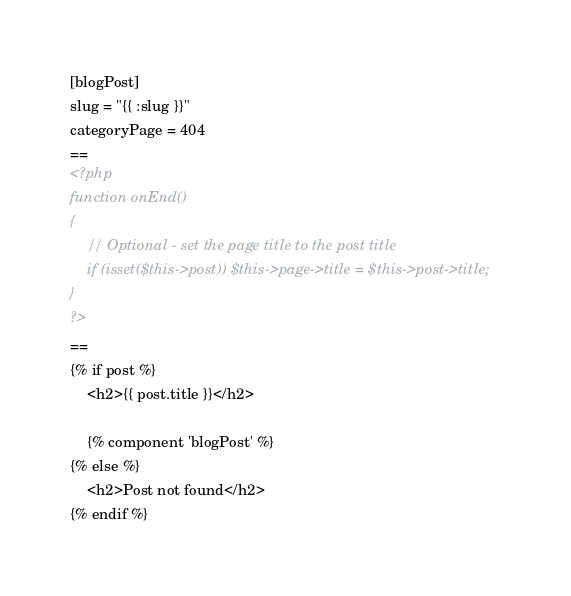<code> <loc_0><loc_0><loc_500><loc_500><_HTML_>
[blogPost]
slug = "{{ :slug }}"
categoryPage = 404
==
<?php
function onEnd()
{
    // Optional - set the page title to the post title
    if (isset($this->post)) $this->page->title = $this->post->title;
}
?>
==
{% if post %}
    <h2>{{ post.title }}</h2>

    {% component 'blogPost' %}
{% else %}
    <h2>Post not found</h2>
{% endif %}</code> 